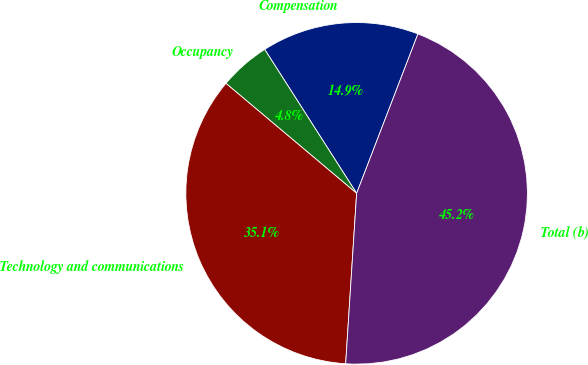<chart> <loc_0><loc_0><loc_500><loc_500><pie_chart><fcel>Compensation<fcel>Occupancy<fcel>Technology and communications<fcel>Total (b)<nl><fcel>14.89%<fcel>4.82%<fcel>35.11%<fcel>45.18%<nl></chart> 